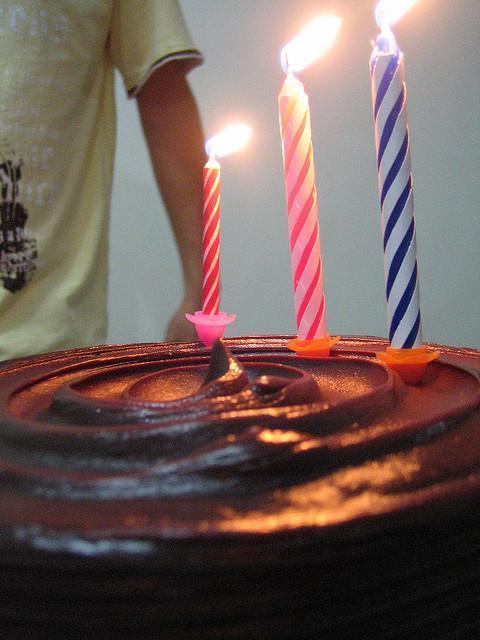Is this affirmation: "The person is behind the cake." correct?
Answer yes or no. Yes. Is this affirmation: "The cake has as a part the person." correct?
Answer yes or no. No. 